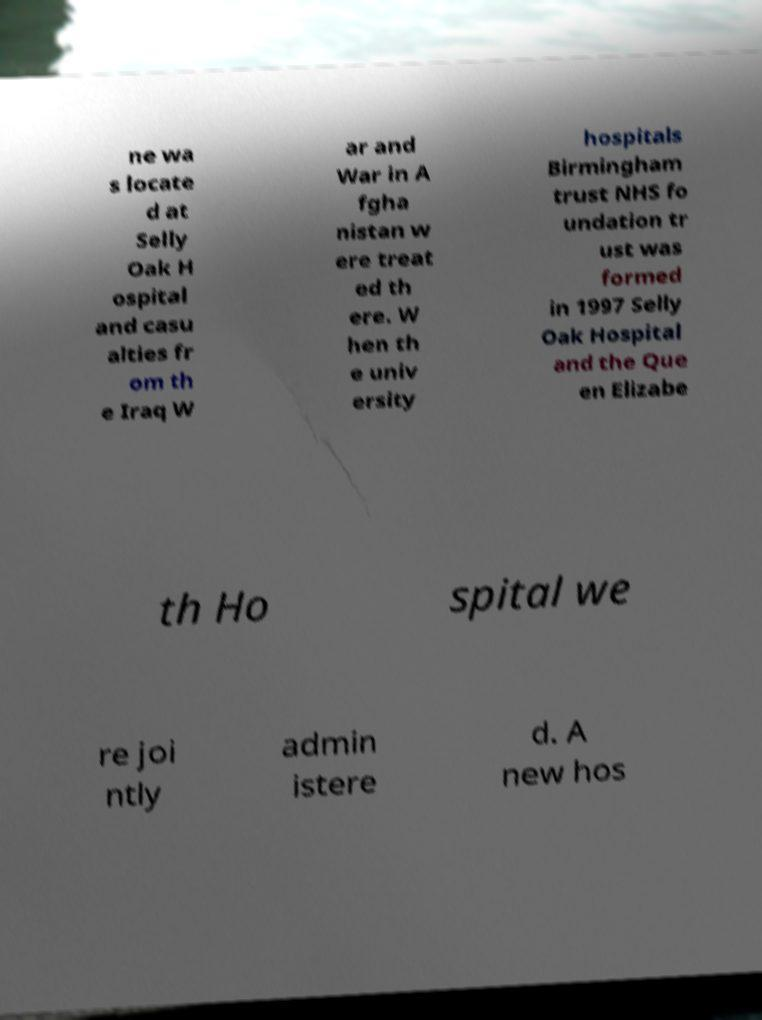Could you assist in decoding the text presented in this image and type it out clearly? ne wa s locate d at Selly Oak H ospital and casu alties fr om th e Iraq W ar and War in A fgha nistan w ere treat ed th ere. W hen th e univ ersity hospitals Birmingham trust NHS fo undation tr ust was formed in 1997 Selly Oak Hospital and the Que en Elizabe th Ho spital we re joi ntly admin istere d. A new hos 